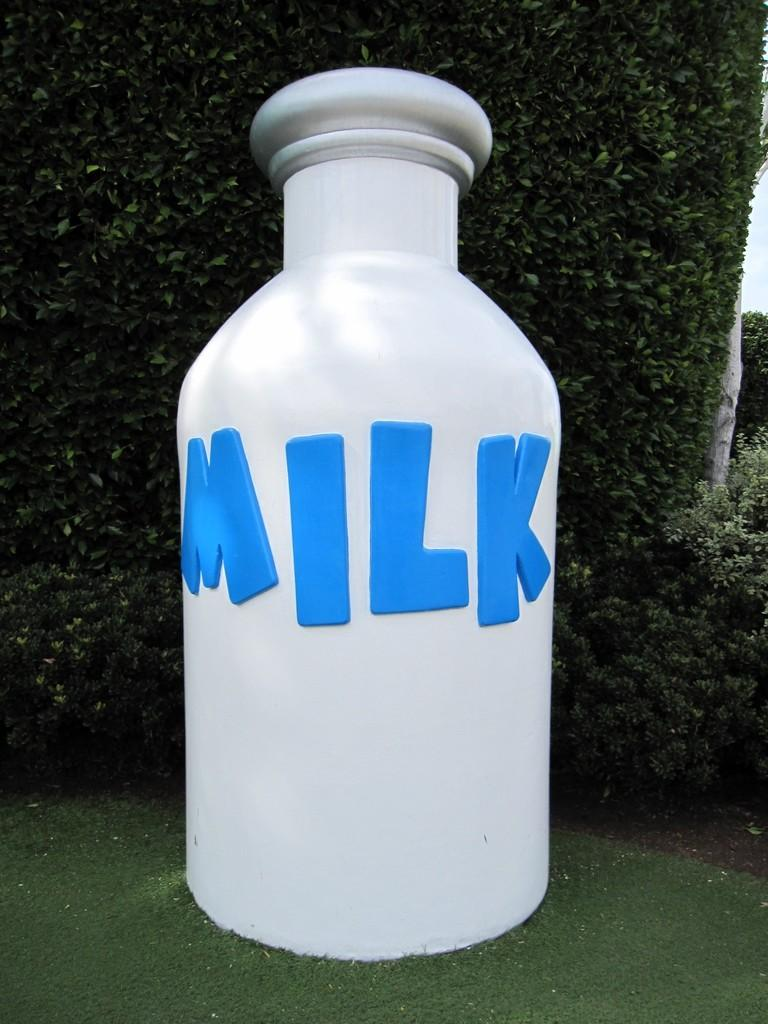<image>
Give a short and clear explanation of the subsequent image. A large display of milk sits in a yard. 